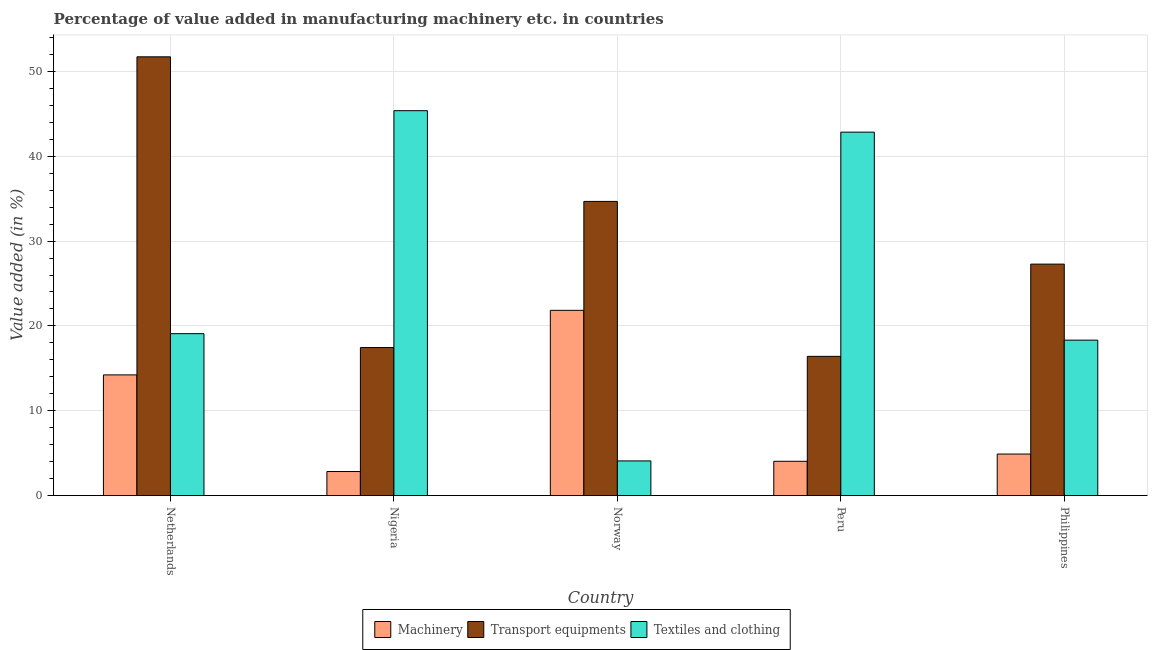Are the number of bars per tick equal to the number of legend labels?
Make the answer very short. Yes. Are the number of bars on each tick of the X-axis equal?
Give a very brief answer. Yes. How many bars are there on the 2nd tick from the left?
Your response must be concise. 3. How many bars are there on the 1st tick from the right?
Provide a succinct answer. 3. What is the label of the 4th group of bars from the left?
Keep it short and to the point. Peru. In how many cases, is the number of bars for a given country not equal to the number of legend labels?
Your answer should be compact. 0. What is the value added in manufacturing transport equipments in Peru?
Give a very brief answer. 16.41. Across all countries, what is the maximum value added in manufacturing machinery?
Offer a very short reply. 21.84. Across all countries, what is the minimum value added in manufacturing textile and clothing?
Give a very brief answer. 4.08. In which country was the value added in manufacturing textile and clothing minimum?
Provide a succinct answer. Norway. What is the total value added in manufacturing machinery in the graph?
Your answer should be very brief. 47.83. What is the difference between the value added in manufacturing textile and clothing in Nigeria and that in Peru?
Make the answer very short. 2.53. What is the difference between the value added in manufacturing transport equipments in Norway and the value added in manufacturing textile and clothing in Peru?
Ensure brevity in your answer.  -8.16. What is the average value added in manufacturing textile and clothing per country?
Make the answer very short. 25.94. What is the difference between the value added in manufacturing transport equipments and value added in manufacturing machinery in Philippines?
Offer a terse response. 22.39. What is the ratio of the value added in manufacturing transport equipments in Netherlands to that in Norway?
Your response must be concise. 1.49. Is the value added in manufacturing machinery in Nigeria less than that in Peru?
Your answer should be very brief. Yes. What is the difference between the highest and the second highest value added in manufacturing machinery?
Give a very brief answer. 7.61. What is the difference between the highest and the lowest value added in manufacturing transport equipments?
Give a very brief answer. 35.31. What does the 2nd bar from the left in Peru represents?
Your response must be concise. Transport equipments. What does the 2nd bar from the right in Peru represents?
Offer a terse response. Transport equipments. How many bars are there?
Give a very brief answer. 15. Are all the bars in the graph horizontal?
Keep it short and to the point. No. How many countries are there in the graph?
Keep it short and to the point. 5. Are the values on the major ticks of Y-axis written in scientific E-notation?
Your response must be concise. No. Does the graph contain any zero values?
Give a very brief answer. No. Does the graph contain grids?
Your response must be concise. Yes. Where does the legend appear in the graph?
Ensure brevity in your answer.  Bottom center. What is the title of the graph?
Make the answer very short. Percentage of value added in manufacturing machinery etc. in countries. What is the label or title of the Y-axis?
Your response must be concise. Value added (in %). What is the Value added (in %) in Machinery in Netherlands?
Give a very brief answer. 14.23. What is the Value added (in %) of Transport equipments in Netherlands?
Your response must be concise. 51.72. What is the Value added (in %) of Textiles and clothing in Netherlands?
Provide a succinct answer. 19.08. What is the Value added (in %) in Machinery in Nigeria?
Offer a very short reply. 2.83. What is the Value added (in %) of Transport equipments in Nigeria?
Keep it short and to the point. 17.45. What is the Value added (in %) in Textiles and clothing in Nigeria?
Ensure brevity in your answer.  45.37. What is the Value added (in %) of Machinery in Norway?
Give a very brief answer. 21.84. What is the Value added (in %) of Transport equipments in Norway?
Provide a succinct answer. 34.68. What is the Value added (in %) of Textiles and clothing in Norway?
Make the answer very short. 4.08. What is the Value added (in %) of Machinery in Peru?
Ensure brevity in your answer.  4.04. What is the Value added (in %) of Transport equipments in Peru?
Provide a short and direct response. 16.41. What is the Value added (in %) of Textiles and clothing in Peru?
Give a very brief answer. 42.84. What is the Value added (in %) in Machinery in Philippines?
Provide a short and direct response. 4.9. What is the Value added (in %) of Transport equipments in Philippines?
Ensure brevity in your answer.  27.28. What is the Value added (in %) in Textiles and clothing in Philippines?
Offer a terse response. 18.32. Across all countries, what is the maximum Value added (in %) in Machinery?
Ensure brevity in your answer.  21.84. Across all countries, what is the maximum Value added (in %) of Transport equipments?
Keep it short and to the point. 51.72. Across all countries, what is the maximum Value added (in %) in Textiles and clothing?
Give a very brief answer. 45.37. Across all countries, what is the minimum Value added (in %) in Machinery?
Your answer should be very brief. 2.83. Across all countries, what is the minimum Value added (in %) of Transport equipments?
Provide a short and direct response. 16.41. Across all countries, what is the minimum Value added (in %) of Textiles and clothing?
Your response must be concise. 4.08. What is the total Value added (in %) of Machinery in the graph?
Provide a short and direct response. 47.83. What is the total Value added (in %) in Transport equipments in the graph?
Your response must be concise. 147.54. What is the total Value added (in %) in Textiles and clothing in the graph?
Provide a short and direct response. 129.7. What is the difference between the Value added (in %) of Machinery in Netherlands and that in Nigeria?
Offer a terse response. 11.39. What is the difference between the Value added (in %) in Transport equipments in Netherlands and that in Nigeria?
Offer a very short reply. 34.27. What is the difference between the Value added (in %) in Textiles and clothing in Netherlands and that in Nigeria?
Your response must be concise. -26.29. What is the difference between the Value added (in %) of Machinery in Netherlands and that in Norway?
Keep it short and to the point. -7.61. What is the difference between the Value added (in %) of Transport equipments in Netherlands and that in Norway?
Your response must be concise. 17.05. What is the difference between the Value added (in %) in Textiles and clothing in Netherlands and that in Norway?
Your answer should be compact. 15. What is the difference between the Value added (in %) in Machinery in Netherlands and that in Peru?
Your answer should be very brief. 10.18. What is the difference between the Value added (in %) of Transport equipments in Netherlands and that in Peru?
Your answer should be very brief. 35.31. What is the difference between the Value added (in %) in Textiles and clothing in Netherlands and that in Peru?
Your answer should be very brief. -23.76. What is the difference between the Value added (in %) of Machinery in Netherlands and that in Philippines?
Give a very brief answer. 9.33. What is the difference between the Value added (in %) in Transport equipments in Netherlands and that in Philippines?
Give a very brief answer. 24.44. What is the difference between the Value added (in %) in Textiles and clothing in Netherlands and that in Philippines?
Your response must be concise. 0.76. What is the difference between the Value added (in %) of Machinery in Nigeria and that in Norway?
Ensure brevity in your answer.  -19. What is the difference between the Value added (in %) in Transport equipments in Nigeria and that in Norway?
Ensure brevity in your answer.  -17.23. What is the difference between the Value added (in %) of Textiles and clothing in Nigeria and that in Norway?
Ensure brevity in your answer.  41.29. What is the difference between the Value added (in %) of Machinery in Nigeria and that in Peru?
Your answer should be very brief. -1.21. What is the difference between the Value added (in %) of Transport equipments in Nigeria and that in Peru?
Your answer should be compact. 1.04. What is the difference between the Value added (in %) in Textiles and clothing in Nigeria and that in Peru?
Give a very brief answer. 2.53. What is the difference between the Value added (in %) in Machinery in Nigeria and that in Philippines?
Give a very brief answer. -2.06. What is the difference between the Value added (in %) in Transport equipments in Nigeria and that in Philippines?
Your response must be concise. -9.83. What is the difference between the Value added (in %) in Textiles and clothing in Nigeria and that in Philippines?
Make the answer very short. 27.05. What is the difference between the Value added (in %) of Machinery in Norway and that in Peru?
Provide a succinct answer. 17.8. What is the difference between the Value added (in %) of Transport equipments in Norway and that in Peru?
Your answer should be very brief. 18.27. What is the difference between the Value added (in %) in Textiles and clothing in Norway and that in Peru?
Provide a succinct answer. -38.76. What is the difference between the Value added (in %) in Machinery in Norway and that in Philippines?
Offer a terse response. 16.94. What is the difference between the Value added (in %) in Transport equipments in Norway and that in Philippines?
Provide a succinct answer. 7.39. What is the difference between the Value added (in %) in Textiles and clothing in Norway and that in Philippines?
Provide a short and direct response. -14.24. What is the difference between the Value added (in %) in Machinery in Peru and that in Philippines?
Provide a short and direct response. -0.85. What is the difference between the Value added (in %) of Transport equipments in Peru and that in Philippines?
Your answer should be compact. -10.87. What is the difference between the Value added (in %) in Textiles and clothing in Peru and that in Philippines?
Ensure brevity in your answer.  24.52. What is the difference between the Value added (in %) in Machinery in Netherlands and the Value added (in %) in Transport equipments in Nigeria?
Your response must be concise. -3.22. What is the difference between the Value added (in %) in Machinery in Netherlands and the Value added (in %) in Textiles and clothing in Nigeria?
Make the answer very short. -31.15. What is the difference between the Value added (in %) of Transport equipments in Netherlands and the Value added (in %) of Textiles and clothing in Nigeria?
Provide a short and direct response. 6.35. What is the difference between the Value added (in %) of Machinery in Netherlands and the Value added (in %) of Transport equipments in Norway?
Your answer should be compact. -20.45. What is the difference between the Value added (in %) of Machinery in Netherlands and the Value added (in %) of Textiles and clothing in Norway?
Your response must be concise. 10.14. What is the difference between the Value added (in %) in Transport equipments in Netherlands and the Value added (in %) in Textiles and clothing in Norway?
Give a very brief answer. 47.64. What is the difference between the Value added (in %) of Machinery in Netherlands and the Value added (in %) of Transport equipments in Peru?
Your answer should be very brief. -2.19. What is the difference between the Value added (in %) of Machinery in Netherlands and the Value added (in %) of Textiles and clothing in Peru?
Your answer should be compact. -28.62. What is the difference between the Value added (in %) of Transport equipments in Netherlands and the Value added (in %) of Textiles and clothing in Peru?
Offer a very short reply. 8.88. What is the difference between the Value added (in %) of Machinery in Netherlands and the Value added (in %) of Transport equipments in Philippines?
Offer a very short reply. -13.06. What is the difference between the Value added (in %) in Machinery in Netherlands and the Value added (in %) in Textiles and clothing in Philippines?
Your answer should be very brief. -4.1. What is the difference between the Value added (in %) of Transport equipments in Netherlands and the Value added (in %) of Textiles and clothing in Philippines?
Provide a succinct answer. 33.4. What is the difference between the Value added (in %) of Machinery in Nigeria and the Value added (in %) of Transport equipments in Norway?
Your answer should be very brief. -31.84. What is the difference between the Value added (in %) of Machinery in Nigeria and the Value added (in %) of Textiles and clothing in Norway?
Provide a succinct answer. -1.25. What is the difference between the Value added (in %) in Transport equipments in Nigeria and the Value added (in %) in Textiles and clothing in Norway?
Offer a terse response. 13.36. What is the difference between the Value added (in %) of Machinery in Nigeria and the Value added (in %) of Transport equipments in Peru?
Provide a short and direct response. -13.58. What is the difference between the Value added (in %) of Machinery in Nigeria and the Value added (in %) of Textiles and clothing in Peru?
Your response must be concise. -40.01. What is the difference between the Value added (in %) in Transport equipments in Nigeria and the Value added (in %) in Textiles and clothing in Peru?
Your answer should be compact. -25.39. What is the difference between the Value added (in %) in Machinery in Nigeria and the Value added (in %) in Transport equipments in Philippines?
Offer a very short reply. -24.45. What is the difference between the Value added (in %) of Machinery in Nigeria and the Value added (in %) of Textiles and clothing in Philippines?
Offer a very short reply. -15.49. What is the difference between the Value added (in %) of Transport equipments in Nigeria and the Value added (in %) of Textiles and clothing in Philippines?
Ensure brevity in your answer.  -0.87. What is the difference between the Value added (in %) of Machinery in Norway and the Value added (in %) of Transport equipments in Peru?
Make the answer very short. 5.43. What is the difference between the Value added (in %) in Machinery in Norway and the Value added (in %) in Textiles and clothing in Peru?
Keep it short and to the point. -21. What is the difference between the Value added (in %) in Transport equipments in Norway and the Value added (in %) in Textiles and clothing in Peru?
Your answer should be compact. -8.16. What is the difference between the Value added (in %) of Machinery in Norway and the Value added (in %) of Transport equipments in Philippines?
Provide a short and direct response. -5.45. What is the difference between the Value added (in %) in Machinery in Norway and the Value added (in %) in Textiles and clothing in Philippines?
Give a very brief answer. 3.51. What is the difference between the Value added (in %) of Transport equipments in Norway and the Value added (in %) of Textiles and clothing in Philippines?
Keep it short and to the point. 16.35. What is the difference between the Value added (in %) of Machinery in Peru and the Value added (in %) of Transport equipments in Philippines?
Offer a terse response. -23.24. What is the difference between the Value added (in %) of Machinery in Peru and the Value added (in %) of Textiles and clothing in Philippines?
Make the answer very short. -14.28. What is the difference between the Value added (in %) in Transport equipments in Peru and the Value added (in %) in Textiles and clothing in Philippines?
Your response must be concise. -1.91. What is the average Value added (in %) in Machinery per country?
Your answer should be compact. 9.57. What is the average Value added (in %) in Transport equipments per country?
Ensure brevity in your answer.  29.51. What is the average Value added (in %) in Textiles and clothing per country?
Provide a succinct answer. 25.94. What is the difference between the Value added (in %) in Machinery and Value added (in %) in Transport equipments in Netherlands?
Ensure brevity in your answer.  -37.5. What is the difference between the Value added (in %) in Machinery and Value added (in %) in Textiles and clothing in Netherlands?
Your response must be concise. -4.86. What is the difference between the Value added (in %) of Transport equipments and Value added (in %) of Textiles and clothing in Netherlands?
Your answer should be very brief. 32.64. What is the difference between the Value added (in %) in Machinery and Value added (in %) in Transport equipments in Nigeria?
Your answer should be compact. -14.61. What is the difference between the Value added (in %) in Machinery and Value added (in %) in Textiles and clothing in Nigeria?
Offer a terse response. -42.54. What is the difference between the Value added (in %) of Transport equipments and Value added (in %) of Textiles and clothing in Nigeria?
Keep it short and to the point. -27.92. What is the difference between the Value added (in %) in Machinery and Value added (in %) in Transport equipments in Norway?
Offer a very short reply. -12.84. What is the difference between the Value added (in %) of Machinery and Value added (in %) of Textiles and clothing in Norway?
Ensure brevity in your answer.  17.75. What is the difference between the Value added (in %) in Transport equipments and Value added (in %) in Textiles and clothing in Norway?
Your answer should be very brief. 30.59. What is the difference between the Value added (in %) of Machinery and Value added (in %) of Transport equipments in Peru?
Ensure brevity in your answer.  -12.37. What is the difference between the Value added (in %) in Machinery and Value added (in %) in Textiles and clothing in Peru?
Give a very brief answer. -38.8. What is the difference between the Value added (in %) in Transport equipments and Value added (in %) in Textiles and clothing in Peru?
Offer a very short reply. -26.43. What is the difference between the Value added (in %) of Machinery and Value added (in %) of Transport equipments in Philippines?
Give a very brief answer. -22.39. What is the difference between the Value added (in %) in Machinery and Value added (in %) in Textiles and clothing in Philippines?
Your answer should be very brief. -13.43. What is the difference between the Value added (in %) in Transport equipments and Value added (in %) in Textiles and clothing in Philippines?
Your answer should be compact. 8.96. What is the ratio of the Value added (in %) of Machinery in Netherlands to that in Nigeria?
Provide a succinct answer. 5.02. What is the ratio of the Value added (in %) in Transport equipments in Netherlands to that in Nigeria?
Provide a succinct answer. 2.96. What is the ratio of the Value added (in %) in Textiles and clothing in Netherlands to that in Nigeria?
Provide a short and direct response. 0.42. What is the ratio of the Value added (in %) of Machinery in Netherlands to that in Norway?
Provide a short and direct response. 0.65. What is the ratio of the Value added (in %) of Transport equipments in Netherlands to that in Norway?
Your answer should be compact. 1.49. What is the ratio of the Value added (in %) of Textiles and clothing in Netherlands to that in Norway?
Provide a succinct answer. 4.67. What is the ratio of the Value added (in %) of Machinery in Netherlands to that in Peru?
Ensure brevity in your answer.  3.52. What is the ratio of the Value added (in %) in Transport equipments in Netherlands to that in Peru?
Provide a succinct answer. 3.15. What is the ratio of the Value added (in %) of Textiles and clothing in Netherlands to that in Peru?
Your answer should be very brief. 0.45. What is the ratio of the Value added (in %) of Machinery in Netherlands to that in Philippines?
Your answer should be compact. 2.91. What is the ratio of the Value added (in %) in Transport equipments in Netherlands to that in Philippines?
Your answer should be compact. 1.9. What is the ratio of the Value added (in %) of Textiles and clothing in Netherlands to that in Philippines?
Make the answer very short. 1.04. What is the ratio of the Value added (in %) of Machinery in Nigeria to that in Norway?
Give a very brief answer. 0.13. What is the ratio of the Value added (in %) in Transport equipments in Nigeria to that in Norway?
Your answer should be compact. 0.5. What is the ratio of the Value added (in %) of Textiles and clothing in Nigeria to that in Norway?
Your response must be concise. 11.11. What is the ratio of the Value added (in %) of Machinery in Nigeria to that in Peru?
Your answer should be compact. 0.7. What is the ratio of the Value added (in %) of Transport equipments in Nigeria to that in Peru?
Your answer should be very brief. 1.06. What is the ratio of the Value added (in %) in Textiles and clothing in Nigeria to that in Peru?
Give a very brief answer. 1.06. What is the ratio of the Value added (in %) in Machinery in Nigeria to that in Philippines?
Make the answer very short. 0.58. What is the ratio of the Value added (in %) of Transport equipments in Nigeria to that in Philippines?
Your answer should be compact. 0.64. What is the ratio of the Value added (in %) in Textiles and clothing in Nigeria to that in Philippines?
Your answer should be very brief. 2.48. What is the ratio of the Value added (in %) in Machinery in Norway to that in Peru?
Your response must be concise. 5.4. What is the ratio of the Value added (in %) in Transport equipments in Norway to that in Peru?
Offer a very short reply. 2.11. What is the ratio of the Value added (in %) of Textiles and clothing in Norway to that in Peru?
Ensure brevity in your answer.  0.1. What is the ratio of the Value added (in %) of Machinery in Norway to that in Philippines?
Offer a terse response. 4.46. What is the ratio of the Value added (in %) of Transport equipments in Norway to that in Philippines?
Make the answer very short. 1.27. What is the ratio of the Value added (in %) in Textiles and clothing in Norway to that in Philippines?
Your answer should be very brief. 0.22. What is the ratio of the Value added (in %) of Machinery in Peru to that in Philippines?
Your answer should be very brief. 0.83. What is the ratio of the Value added (in %) of Transport equipments in Peru to that in Philippines?
Offer a very short reply. 0.6. What is the ratio of the Value added (in %) of Textiles and clothing in Peru to that in Philippines?
Offer a very short reply. 2.34. What is the difference between the highest and the second highest Value added (in %) in Machinery?
Make the answer very short. 7.61. What is the difference between the highest and the second highest Value added (in %) of Transport equipments?
Offer a terse response. 17.05. What is the difference between the highest and the second highest Value added (in %) of Textiles and clothing?
Give a very brief answer. 2.53. What is the difference between the highest and the lowest Value added (in %) in Machinery?
Give a very brief answer. 19. What is the difference between the highest and the lowest Value added (in %) in Transport equipments?
Provide a short and direct response. 35.31. What is the difference between the highest and the lowest Value added (in %) of Textiles and clothing?
Provide a short and direct response. 41.29. 